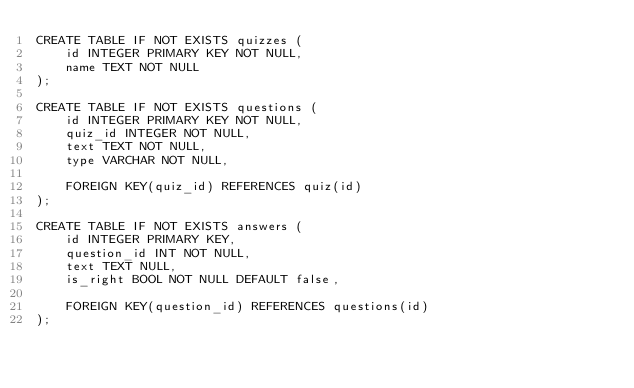Convert code to text. <code><loc_0><loc_0><loc_500><loc_500><_SQL_>CREATE TABLE IF NOT EXISTS quizzes (
	id INTEGER PRIMARY KEY NOT NULL,
	name TEXT NOT NULL
);

CREATE TABLE IF NOT EXISTS questions (
	id INTEGER PRIMARY KEY NOT NULL,
	quiz_id INTEGER NOT NULL,
	text TEXT NOT NULL,
	type VARCHAR NOT NULL,

	FOREIGN KEY(quiz_id) REFERENCES quiz(id)
);

CREATE TABLE IF NOT EXISTS answers (
	id INTEGER PRIMARY KEY,
	question_id INT NOT NULL,
	text TEXT NULL,
	is_right BOOL NOT NULL DEFAULT false,
	
	FOREIGN KEY(question_id) REFERENCES questions(id)
);
</code> 